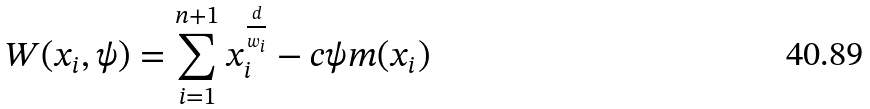Convert formula to latex. <formula><loc_0><loc_0><loc_500><loc_500>W ( x _ { i } , \psi ) = \sum _ { i = 1 } ^ { n + 1 } x _ { i } ^ { \frac { d } { w _ { i } } } - c \psi m ( x _ { i } )</formula> 